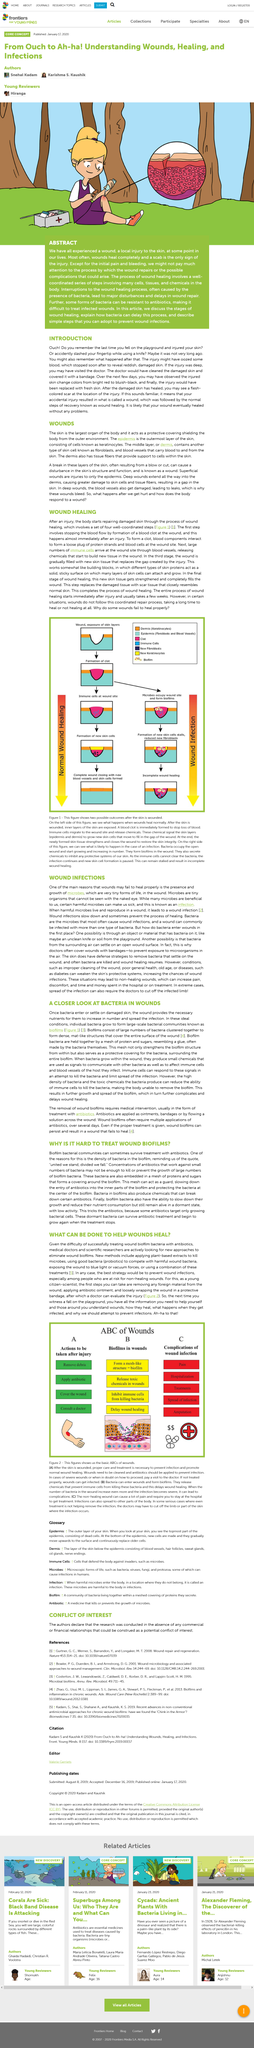Point out several critical features in this image. A wound is a break in the epidermis and dermis layers of the skin, which can result in damage to the underlying tissue. The dermis is the middle layer of skin, which is also referred to as the middle layer of skin. The epidermis is the outermost layer of skin. 